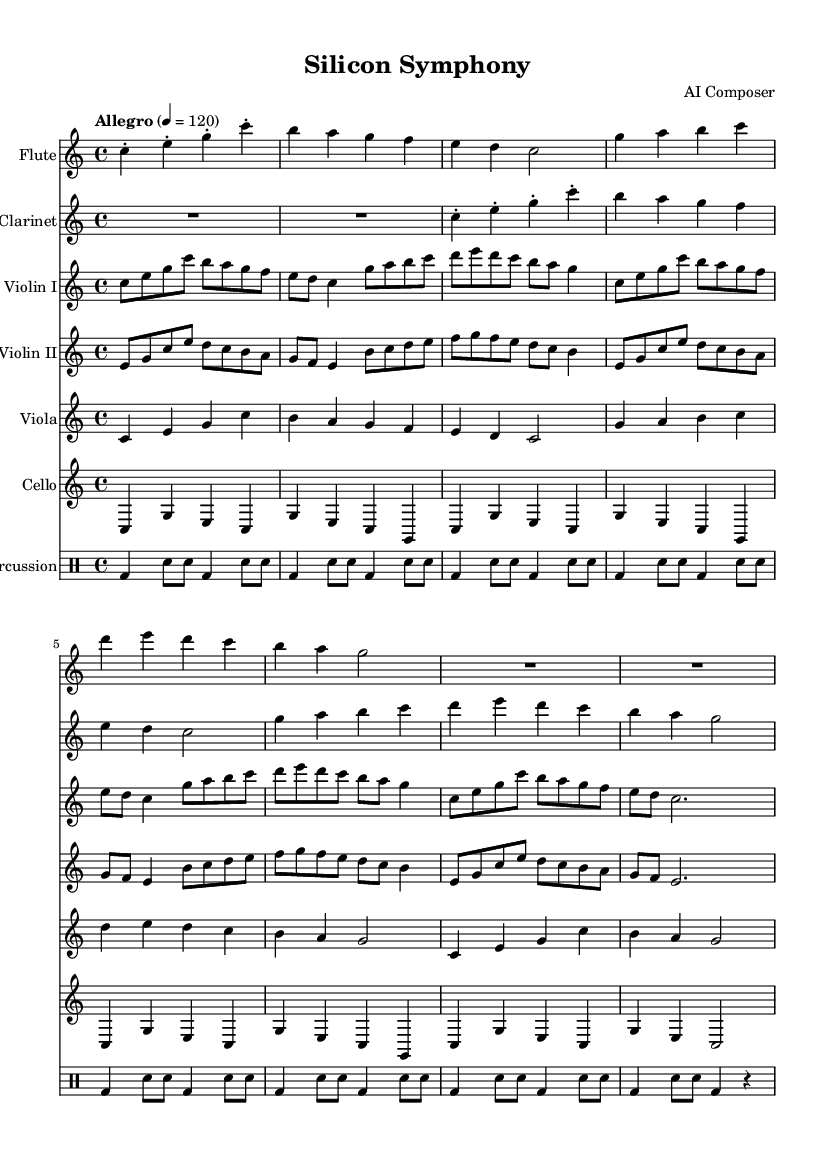What is the key signature of this music? The key signature is indicated at the beginning of the music, which shows no sharps or flats, thus indicating C major.
Answer: C major What is the time signature of this composition? The time signature is displayed at the beginning, showing a 4 over 4, which means there are four beats in a measure.
Answer: 4/4 What is the tempo marking for this piece? The tempo marking is found at the beginning of the score, stating "Allegro" with a metronome marking of 120 beats per minute.
Answer: Allegro Which instruments are included in this symphony? By examining the score, we can see separate staves for Flute, Clarinet, Violin I, Violin II, Viola, Cello, and Percussion.
Answer: Flute, Clarinet, Violin I, Violin II, Viola, Cello, Percussion How many measures are there in the flute part? Count the measures in the flute part, noticing each group of notes outside of the bar lines. There are a total of 8 measures.
Answer: 8 In which section does the cello part introduce a repetitive motif? Looking at the cello part, the repetitive motif can be found in measures 1 through 8, where the same pattern of notes appears.
Answer: Measures 1-8 What rhythmic pattern is used in the percussion section? The rhythmic pattern in the percussion section features a repeated alternating bass drum and snare drum pattern, indicated clearly through the drummode notation.
Answer: Alternating bass drum and snare drum 